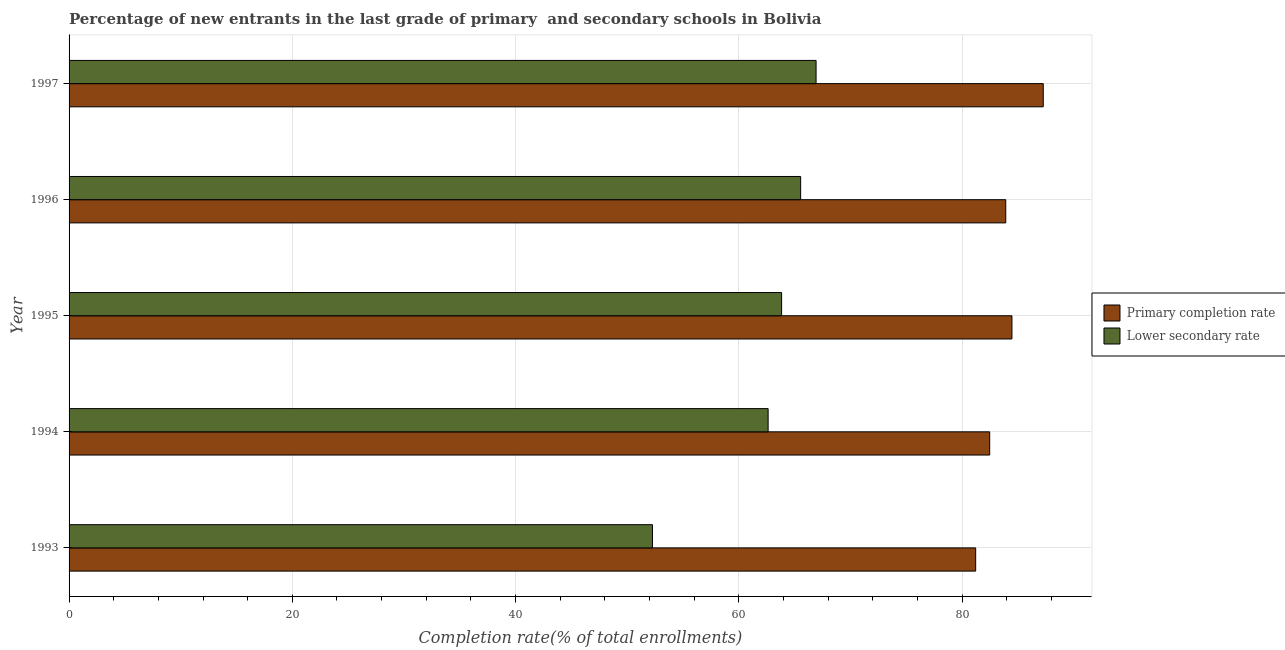How many groups of bars are there?
Offer a very short reply. 5. What is the label of the 4th group of bars from the top?
Give a very brief answer. 1994. What is the completion rate in secondary schools in 1995?
Provide a short and direct response. 63.83. Across all years, what is the maximum completion rate in primary schools?
Your answer should be compact. 87.28. Across all years, what is the minimum completion rate in secondary schools?
Offer a terse response. 52.27. In which year was the completion rate in secondary schools maximum?
Offer a terse response. 1997. What is the total completion rate in primary schools in the graph?
Ensure brevity in your answer.  419.36. What is the difference between the completion rate in primary schools in 1993 and that in 1994?
Offer a terse response. -1.26. What is the difference between the completion rate in secondary schools in 1997 and the completion rate in primary schools in 1995?
Ensure brevity in your answer.  -17.55. What is the average completion rate in secondary schools per year?
Offer a very short reply. 62.24. In the year 1995, what is the difference between the completion rate in secondary schools and completion rate in primary schools?
Ensure brevity in your answer.  -20.64. What is the ratio of the completion rate in secondary schools in 1996 to that in 1997?
Offer a terse response. 0.98. Is the difference between the completion rate in secondary schools in 1993 and 1996 greater than the difference between the completion rate in primary schools in 1993 and 1996?
Your response must be concise. No. What is the difference between the highest and the second highest completion rate in secondary schools?
Provide a short and direct response. 1.38. What is the difference between the highest and the lowest completion rate in primary schools?
Ensure brevity in your answer.  6.05. Is the sum of the completion rate in primary schools in 1993 and 1995 greater than the maximum completion rate in secondary schools across all years?
Keep it short and to the point. Yes. What does the 1st bar from the top in 1993 represents?
Your answer should be compact. Lower secondary rate. What does the 1st bar from the bottom in 1995 represents?
Provide a succinct answer. Primary completion rate. How many years are there in the graph?
Offer a terse response. 5. What is the difference between two consecutive major ticks on the X-axis?
Ensure brevity in your answer.  20. Are the values on the major ticks of X-axis written in scientific E-notation?
Your response must be concise. No. How are the legend labels stacked?
Offer a very short reply. Vertical. What is the title of the graph?
Keep it short and to the point. Percentage of new entrants in the last grade of primary  and secondary schools in Bolivia. Does "Savings" appear as one of the legend labels in the graph?
Your answer should be very brief. No. What is the label or title of the X-axis?
Provide a short and direct response. Completion rate(% of total enrollments). What is the Completion rate(% of total enrollments) of Primary completion rate in 1993?
Make the answer very short. 81.22. What is the Completion rate(% of total enrollments) of Lower secondary rate in 1993?
Make the answer very short. 52.27. What is the Completion rate(% of total enrollments) in Primary completion rate in 1994?
Your answer should be compact. 82.48. What is the Completion rate(% of total enrollments) of Lower secondary rate in 1994?
Provide a succinct answer. 62.63. What is the Completion rate(% of total enrollments) in Primary completion rate in 1995?
Your answer should be compact. 84.47. What is the Completion rate(% of total enrollments) of Lower secondary rate in 1995?
Keep it short and to the point. 63.83. What is the Completion rate(% of total enrollments) in Primary completion rate in 1996?
Offer a very short reply. 83.92. What is the Completion rate(% of total enrollments) in Lower secondary rate in 1996?
Give a very brief answer. 65.54. What is the Completion rate(% of total enrollments) in Primary completion rate in 1997?
Your answer should be very brief. 87.28. What is the Completion rate(% of total enrollments) of Lower secondary rate in 1997?
Provide a short and direct response. 66.92. Across all years, what is the maximum Completion rate(% of total enrollments) of Primary completion rate?
Offer a very short reply. 87.28. Across all years, what is the maximum Completion rate(% of total enrollments) of Lower secondary rate?
Your answer should be compact. 66.92. Across all years, what is the minimum Completion rate(% of total enrollments) of Primary completion rate?
Offer a terse response. 81.22. Across all years, what is the minimum Completion rate(% of total enrollments) of Lower secondary rate?
Offer a very short reply. 52.27. What is the total Completion rate(% of total enrollments) of Primary completion rate in the graph?
Your response must be concise. 419.36. What is the total Completion rate(% of total enrollments) of Lower secondary rate in the graph?
Keep it short and to the point. 311.19. What is the difference between the Completion rate(% of total enrollments) of Primary completion rate in 1993 and that in 1994?
Keep it short and to the point. -1.26. What is the difference between the Completion rate(% of total enrollments) in Lower secondary rate in 1993 and that in 1994?
Give a very brief answer. -10.36. What is the difference between the Completion rate(% of total enrollments) of Primary completion rate in 1993 and that in 1995?
Keep it short and to the point. -3.25. What is the difference between the Completion rate(% of total enrollments) of Lower secondary rate in 1993 and that in 1995?
Make the answer very short. -11.57. What is the difference between the Completion rate(% of total enrollments) in Primary completion rate in 1993 and that in 1996?
Make the answer very short. -2.69. What is the difference between the Completion rate(% of total enrollments) of Lower secondary rate in 1993 and that in 1996?
Your response must be concise. -13.27. What is the difference between the Completion rate(% of total enrollments) of Primary completion rate in 1993 and that in 1997?
Make the answer very short. -6.05. What is the difference between the Completion rate(% of total enrollments) in Lower secondary rate in 1993 and that in 1997?
Offer a very short reply. -14.66. What is the difference between the Completion rate(% of total enrollments) of Primary completion rate in 1994 and that in 1995?
Provide a short and direct response. -1.99. What is the difference between the Completion rate(% of total enrollments) of Lower secondary rate in 1994 and that in 1995?
Provide a succinct answer. -1.21. What is the difference between the Completion rate(% of total enrollments) of Primary completion rate in 1994 and that in 1996?
Keep it short and to the point. -1.44. What is the difference between the Completion rate(% of total enrollments) in Lower secondary rate in 1994 and that in 1996?
Your answer should be very brief. -2.91. What is the difference between the Completion rate(% of total enrollments) in Primary completion rate in 1994 and that in 1997?
Give a very brief answer. -4.8. What is the difference between the Completion rate(% of total enrollments) of Lower secondary rate in 1994 and that in 1997?
Ensure brevity in your answer.  -4.29. What is the difference between the Completion rate(% of total enrollments) in Primary completion rate in 1995 and that in 1996?
Keep it short and to the point. 0.55. What is the difference between the Completion rate(% of total enrollments) of Lower secondary rate in 1995 and that in 1996?
Make the answer very short. -1.71. What is the difference between the Completion rate(% of total enrollments) in Primary completion rate in 1995 and that in 1997?
Ensure brevity in your answer.  -2.81. What is the difference between the Completion rate(% of total enrollments) of Lower secondary rate in 1995 and that in 1997?
Your answer should be compact. -3.09. What is the difference between the Completion rate(% of total enrollments) in Primary completion rate in 1996 and that in 1997?
Provide a succinct answer. -3.36. What is the difference between the Completion rate(% of total enrollments) in Lower secondary rate in 1996 and that in 1997?
Keep it short and to the point. -1.38. What is the difference between the Completion rate(% of total enrollments) in Primary completion rate in 1993 and the Completion rate(% of total enrollments) in Lower secondary rate in 1994?
Provide a succinct answer. 18.59. What is the difference between the Completion rate(% of total enrollments) in Primary completion rate in 1993 and the Completion rate(% of total enrollments) in Lower secondary rate in 1995?
Offer a terse response. 17.39. What is the difference between the Completion rate(% of total enrollments) in Primary completion rate in 1993 and the Completion rate(% of total enrollments) in Lower secondary rate in 1996?
Provide a succinct answer. 15.68. What is the difference between the Completion rate(% of total enrollments) of Primary completion rate in 1993 and the Completion rate(% of total enrollments) of Lower secondary rate in 1997?
Your response must be concise. 14.3. What is the difference between the Completion rate(% of total enrollments) of Primary completion rate in 1994 and the Completion rate(% of total enrollments) of Lower secondary rate in 1995?
Provide a short and direct response. 18.64. What is the difference between the Completion rate(% of total enrollments) in Primary completion rate in 1994 and the Completion rate(% of total enrollments) in Lower secondary rate in 1996?
Provide a short and direct response. 16.94. What is the difference between the Completion rate(% of total enrollments) in Primary completion rate in 1994 and the Completion rate(% of total enrollments) in Lower secondary rate in 1997?
Provide a succinct answer. 15.55. What is the difference between the Completion rate(% of total enrollments) of Primary completion rate in 1995 and the Completion rate(% of total enrollments) of Lower secondary rate in 1996?
Offer a very short reply. 18.93. What is the difference between the Completion rate(% of total enrollments) in Primary completion rate in 1995 and the Completion rate(% of total enrollments) in Lower secondary rate in 1997?
Give a very brief answer. 17.55. What is the difference between the Completion rate(% of total enrollments) in Primary completion rate in 1996 and the Completion rate(% of total enrollments) in Lower secondary rate in 1997?
Offer a very short reply. 16.99. What is the average Completion rate(% of total enrollments) of Primary completion rate per year?
Provide a short and direct response. 83.87. What is the average Completion rate(% of total enrollments) in Lower secondary rate per year?
Provide a short and direct response. 62.24. In the year 1993, what is the difference between the Completion rate(% of total enrollments) of Primary completion rate and Completion rate(% of total enrollments) of Lower secondary rate?
Ensure brevity in your answer.  28.95. In the year 1994, what is the difference between the Completion rate(% of total enrollments) in Primary completion rate and Completion rate(% of total enrollments) in Lower secondary rate?
Provide a short and direct response. 19.85. In the year 1995, what is the difference between the Completion rate(% of total enrollments) of Primary completion rate and Completion rate(% of total enrollments) of Lower secondary rate?
Offer a very short reply. 20.64. In the year 1996, what is the difference between the Completion rate(% of total enrollments) in Primary completion rate and Completion rate(% of total enrollments) in Lower secondary rate?
Provide a short and direct response. 18.37. In the year 1997, what is the difference between the Completion rate(% of total enrollments) in Primary completion rate and Completion rate(% of total enrollments) in Lower secondary rate?
Give a very brief answer. 20.35. What is the ratio of the Completion rate(% of total enrollments) of Primary completion rate in 1993 to that in 1994?
Keep it short and to the point. 0.98. What is the ratio of the Completion rate(% of total enrollments) of Lower secondary rate in 1993 to that in 1994?
Provide a short and direct response. 0.83. What is the ratio of the Completion rate(% of total enrollments) in Primary completion rate in 1993 to that in 1995?
Offer a very short reply. 0.96. What is the ratio of the Completion rate(% of total enrollments) in Lower secondary rate in 1993 to that in 1995?
Offer a terse response. 0.82. What is the ratio of the Completion rate(% of total enrollments) in Primary completion rate in 1993 to that in 1996?
Provide a succinct answer. 0.97. What is the ratio of the Completion rate(% of total enrollments) of Lower secondary rate in 1993 to that in 1996?
Give a very brief answer. 0.8. What is the ratio of the Completion rate(% of total enrollments) in Primary completion rate in 1993 to that in 1997?
Your answer should be very brief. 0.93. What is the ratio of the Completion rate(% of total enrollments) in Lower secondary rate in 1993 to that in 1997?
Offer a terse response. 0.78. What is the ratio of the Completion rate(% of total enrollments) in Primary completion rate in 1994 to that in 1995?
Provide a short and direct response. 0.98. What is the ratio of the Completion rate(% of total enrollments) in Lower secondary rate in 1994 to that in 1995?
Offer a terse response. 0.98. What is the ratio of the Completion rate(% of total enrollments) in Primary completion rate in 1994 to that in 1996?
Your answer should be compact. 0.98. What is the ratio of the Completion rate(% of total enrollments) of Lower secondary rate in 1994 to that in 1996?
Offer a terse response. 0.96. What is the ratio of the Completion rate(% of total enrollments) of Primary completion rate in 1994 to that in 1997?
Offer a terse response. 0.94. What is the ratio of the Completion rate(% of total enrollments) of Lower secondary rate in 1994 to that in 1997?
Offer a terse response. 0.94. What is the ratio of the Completion rate(% of total enrollments) in Primary completion rate in 1995 to that in 1996?
Offer a terse response. 1.01. What is the ratio of the Completion rate(% of total enrollments) of Lower secondary rate in 1995 to that in 1996?
Offer a terse response. 0.97. What is the ratio of the Completion rate(% of total enrollments) in Primary completion rate in 1995 to that in 1997?
Offer a terse response. 0.97. What is the ratio of the Completion rate(% of total enrollments) of Lower secondary rate in 1995 to that in 1997?
Your answer should be compact. 0.95. What is the ratio of the Completion rate(% of total enrollments) in Primary completion rate in 1996 to that in 1997?
Your answer should be very brief. 0.96. What is the ratio of the Completion rate(% of total enrollments) of Lower secondary rate in 1996 to that in 1997?
Offer a very short reply. 0.98. What is the difference between the highest and the second highest Completion rate(% of total enrollments) of Primary completion rate?
Your answer should be compact. 2.81. What is the difference between the highest and the second highest Completion rate(% of total enrollments) in Lower secondary rate?
Make the answer very short. 1.38. What is the difference between the highest and the lowest Completion rate(% of total enrollments) in Primary completion rate?
Ensure brevity in your answer.  6.05. What is the difference between the highest and the lowest Completion rate(% of total enrollments) in Lower secondary rate?
Your response must be concise. 14.66. 